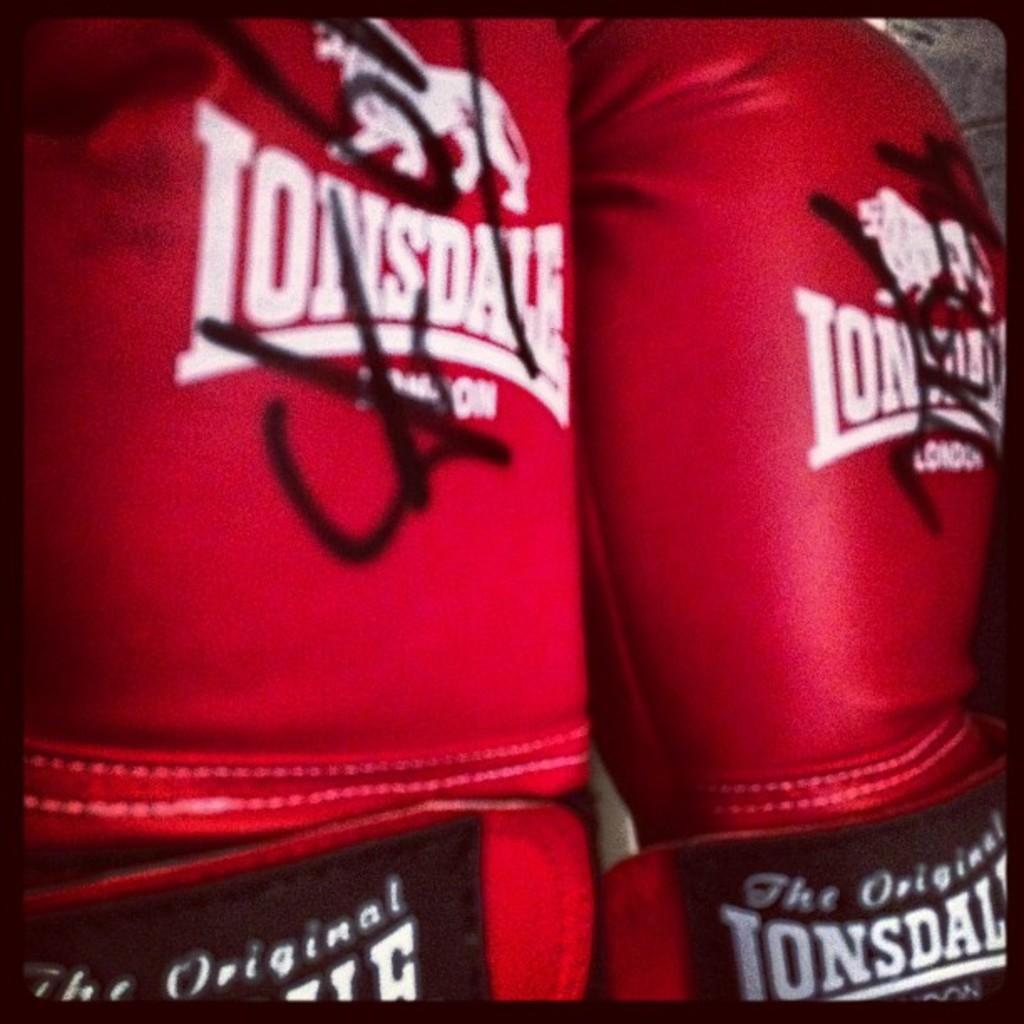In one or two sentences, can you explain what this image depicts? In this picture I can see there is a pair of red color boxing gloves and there is a logo on it. 